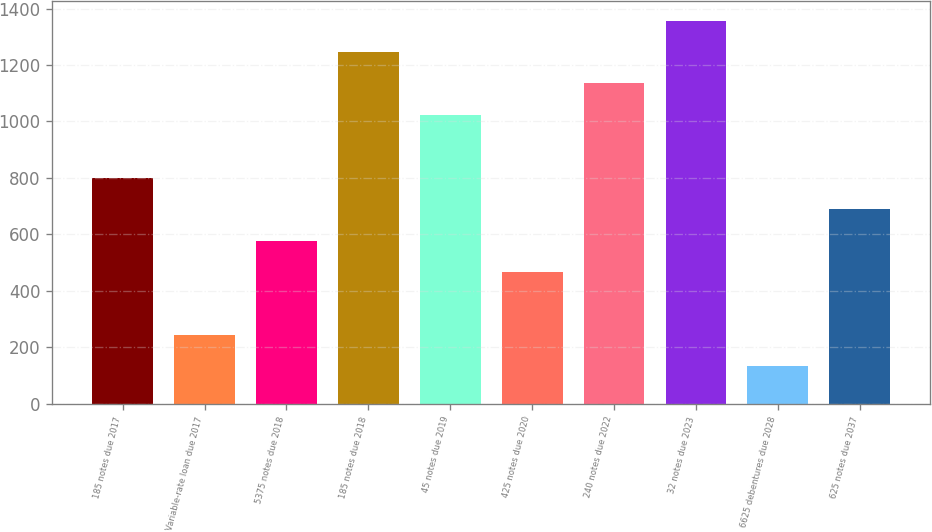<chart> <loc_0><loc_0><loc_500><loc_500><bar_chart><fcel>185 notes due 2017<fcel>Variable-rate loan due 2017<fcel>5375 notes due 2018<fcel>185 notes due 2018<fcel>45 notes due 2019<fcel>425 notes due 2020<fcel>240 notes due 2022<fcel>32 notes due 2023<fcel>6625 debentures due 2028<fcel>625 notes due 2037<nl><fcel>800.8<fcel>244.3<fcel>578.2<fcel>1246<fcel>1023.4<fcel>466.9<fcel>1134.7<fcel>1357.3<fcel>133<fcel>689.5<nl></chart> 